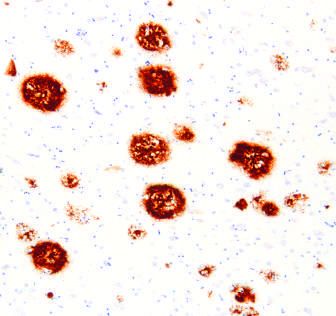does immunohistochemical stain for abeta?
Answer the question using a single word or phrase. Yes 